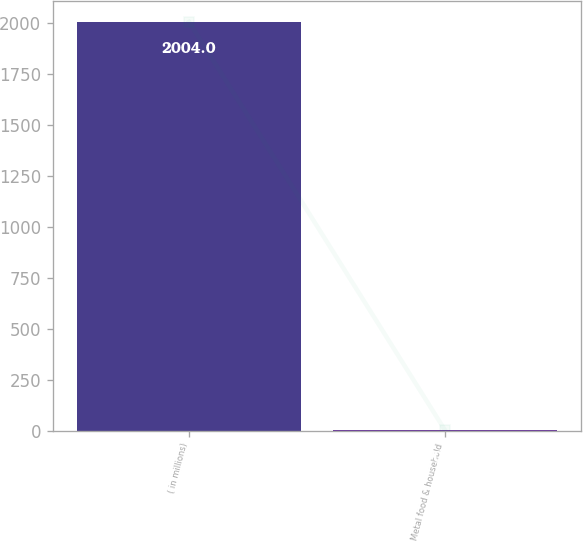Convert chart to OTSL. <chart><loc_0><loc_0><loc_500><loc_500><bar_chart><fcel>( in millions)<fcel>Metal food & household<nl><fcel>2004<fcel>0.4<nl></chart> 